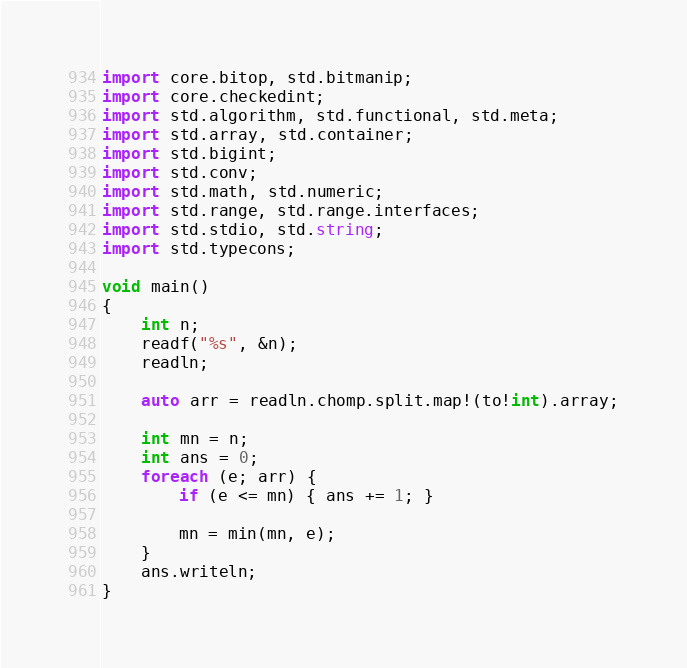<code> <loc_0><loc_0><loc_500><loc_500><_D_>import core.bitop, std.bitmanip;
import core.checkedint;
import std.algorithm, std.functional, std.meta;
import std.array, std.container;
import std.bigint;
import std.conv;
import std.math, std.numeric;
import std.range, std.range.interfaces;
import std.stdio, std.string;
import std.typecons;

void main()
{
    int n;
    readf("%s", &n);
    readln;
    
    auto arr = readln.chomp.split.map!(to!int).array;
    
    int mn = n;
    int ans = 0;
    foreach (e; arr) {
        if (e <= mn) { ans += 1; }
        
        mn = min(mn, e);
    }
    ans.writeln;
}</code> 